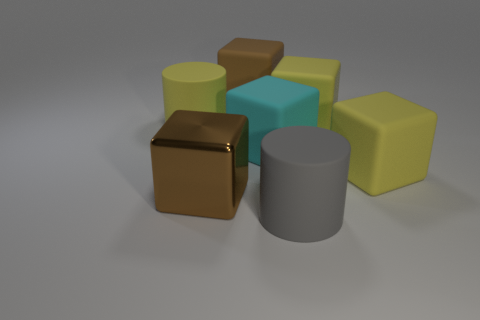Are there any large matte blocks of the same color as the large metal thing?
Provide a succinct answer. Yes. There is another big thing that is the same color as the metal object; what shape is it?
Make the answer very short. Cube. How many things are brown objects or cylinders behind the big shiny object?
Keep it short and to the point. 3. There is a large cylinder that is in front of the big yellow object to the left of the brown metallic object; what is its color?
Your answer should be very brief. Gray. Does the matte block that is on the left side of the cyan matte cube have the same color as the big shiny block?
Provide a short and direct response. Yes. There is a brown cube that is to the left of the big brown rubber thing; what is it made of?
Give a very brief answer. Metal. What size is the brown rubber thing?
Give a very brief answer. Large. Is the brown cube right of the brown metal object made of the same material as the large gray thing?
Provide a succinct answer. Yes. What number of cubes are there?
Keep it short and to the point. 5. How many objects are either large brown matte objects or large yellow blocks?
Your answer should be compact. 3. 